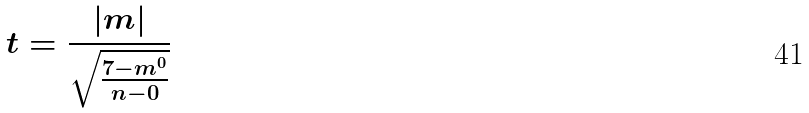Convert formula to latex. <formula><loc_0><loc_0><loc_500><loc_500>t = \frac { | m | } { \sqrt { \frac { 7 - m ^ { 0 } } { n - 0 } } }</formula> 